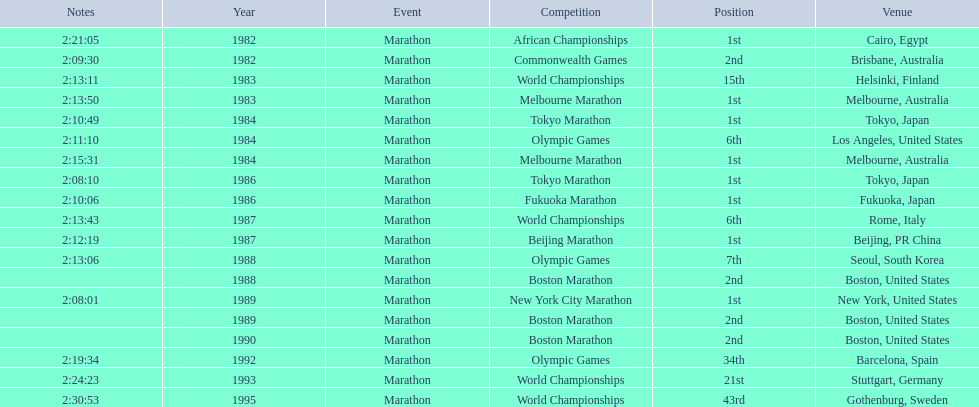What are all of the juma ikangaa competitions? African Championships, Commonwealth Games, World Championships, Melbourne Marathon, Tokyo Marathon, Olympic Games, Melbourne Marathon, Tokyo Marathon, Fukuoka Marathon, World Championships, Beijing Marathon, Olympic Games, Boston Marathon, New York City Marathon, Boston Marathon, Boston Marathon, Olympic Games, World Championships, World Championships. Which of these competitions did not take place in the united states? African Championships, Commonwealth Games, World Championships, Melbourne Marathon, Tokyo Marathon, Melbourne Marathon, Tokyo Marathon, Fukuoka Marathon, World Championships, Beijing Marathon, Olympic Games, Olympic Games, World Championships, World Championships. Out of these, which of them took place in asia? Tokyo Marathon, Tokyo Marathon, Fukuoka Marathon, Beijing Marathon, Olympic Games. Which of the remaining competitions took place in china? Beijing Marathon. 